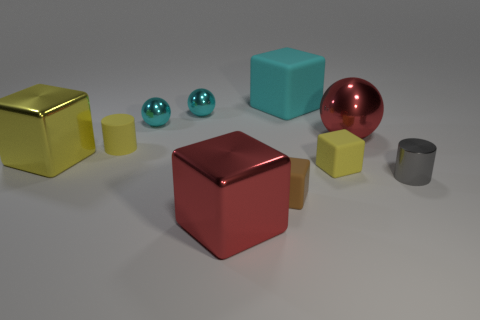Subtract all cyan spheres. How many yellow blocks are left? 2 Subtract 1 cubes. How many cubes are left? 4 Subtract all big shiny cubes. How many cubes are left? 3 Subtract all cyan cubes. How many cubes are left? 4 Subtract all cyan blocks. Subtract all purple cylinders. How many blocks are left? 4 Subtract all spheres. How many objects are left? 7 Subtract all red metal balls. Subtract all tiny brown objects. How many objects are left? 8 Add 4 cylinders. How many cylinders are left? 6 Add 1 red blocks. How many red blocks exist? 2 Subtract 0 green cubes. How many objects are left? 10 